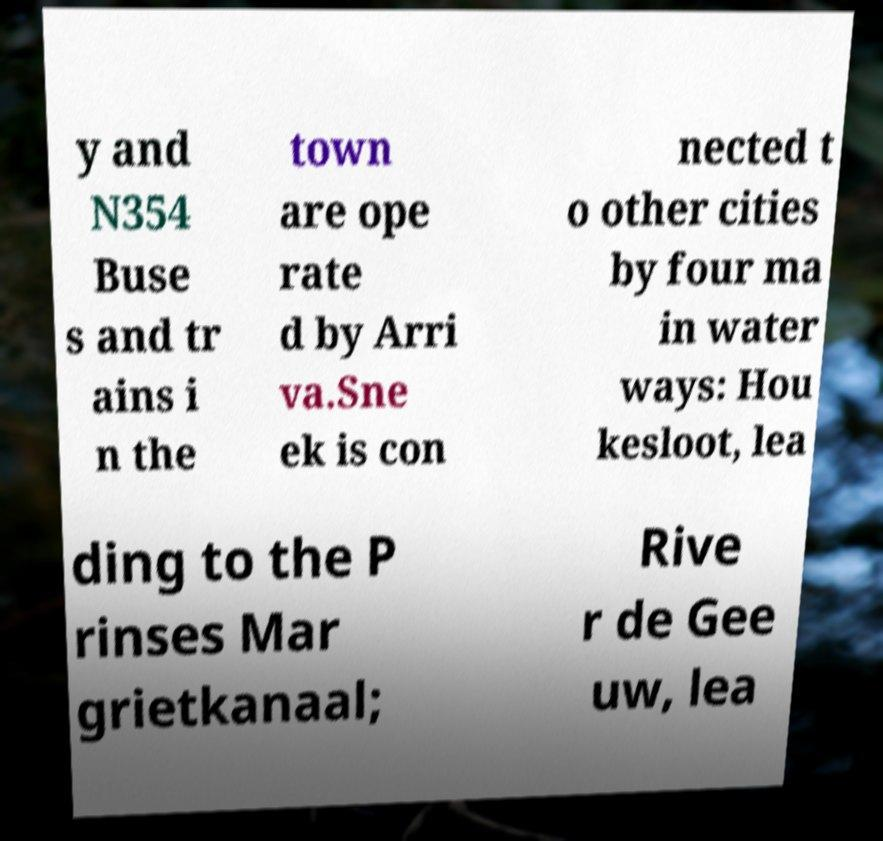Please identify and transcribe the text found in this image. y and N354 Buse s and tr ains i n the town are ope rate d by Arri va.Sne ek is con nected t o other cities by four ma in water ways: Hou kesloot, lea ding to the P rinses Mar grietkanaal; Rive r de Gee uw, lea 